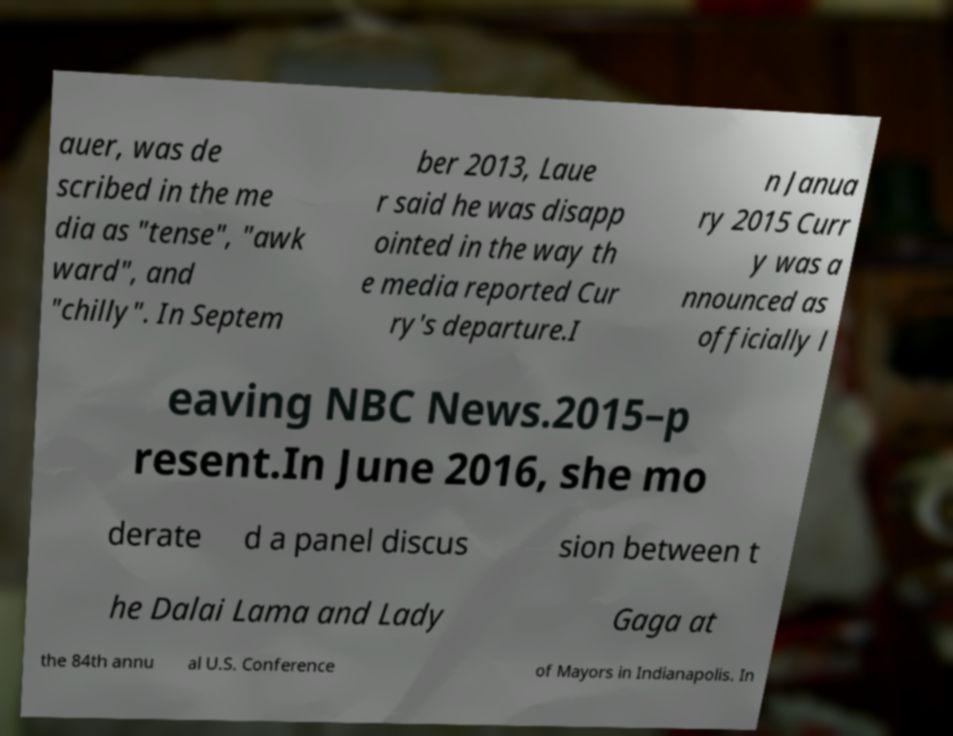What messages or text are displayed in this image? I need them in a readable, typed format. auer, was de scribed in the me dia as "tense", "awk ward", and "chilly". In Septem ber 2013, Laue r said he was disapp ointed in the way th e media reported Cur ry's departure.I n Janua ry 2015 Curr y was a nnounced as officially l eaving NBC News.2015–p resent.In June 2016, she mo derate d a panel discus sion between t he Dalai Lama and Lady Gaga at the 84th annu al U.S. Conference of Mayors in Indianapolis. In 